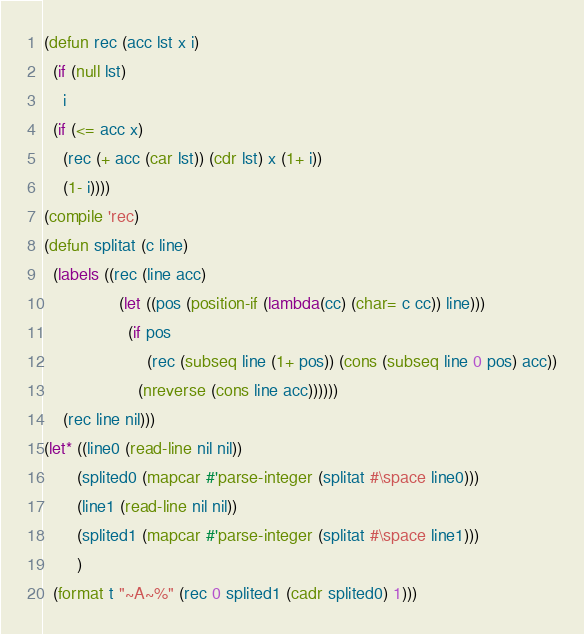<code> <loc_0><loc_0><loc_500><loc_500><_Lisp_>
(defun rec (acc lst x i)
  (if (null lst)
	i
  (if (<= acc x)
	(rec (+ acc (car lst)) (cdr lst) x (1+ i))
	(1- i))))
(compile 'rec)
(defun splitat (c line)
  (labels ((rec (line acc)
				(let ((pos (position-if (lambda(cc) (char= c cc)) line)))
				  (if pos
					  (rec (subseq line (1+ pos)) (cons (subseq line 0 pos) acc))
					(nreverse (cons line acc))))))
	(rec line nil)))
(let* ((line0 (read-line nil nil))
	   (splited0 (mapcar #'parse-integer (splitat #\space line0)))
	   (line1 (read-line nil nil))
	   (splited1 (mapcar #'parse-integer (splitat #\space line1)))
	   )
  (format t "~A~%" (rec 0 splited1 (cadr splited0) 1)))

</code> 